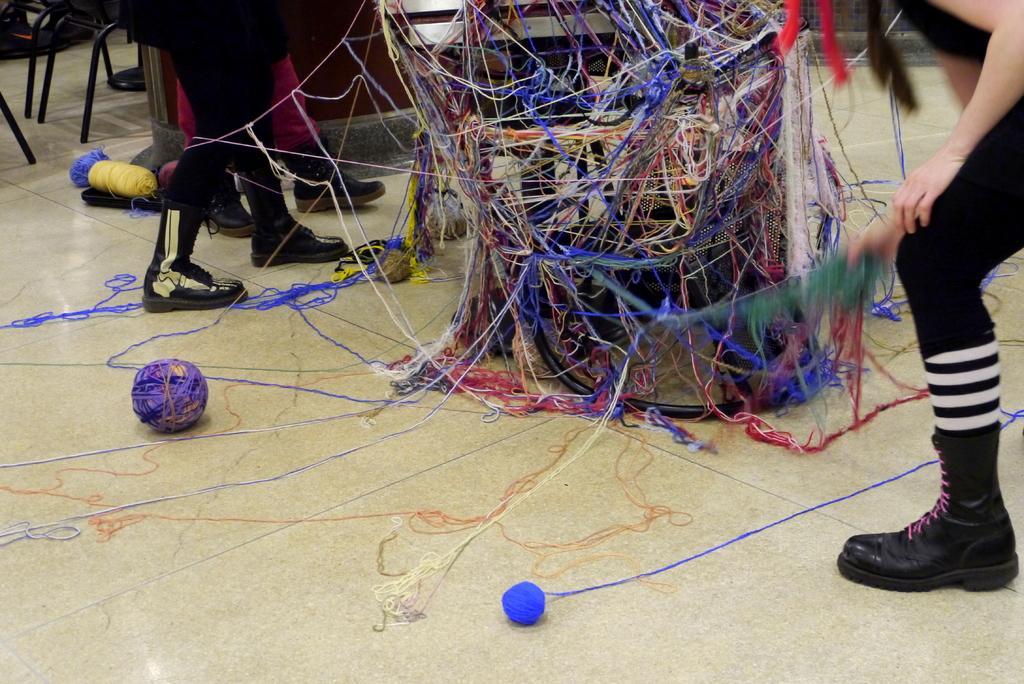Could you give a brief overview of what you see in this image? In this picture we can see the legs of a few people, woolen balls, chairs and other objects. 